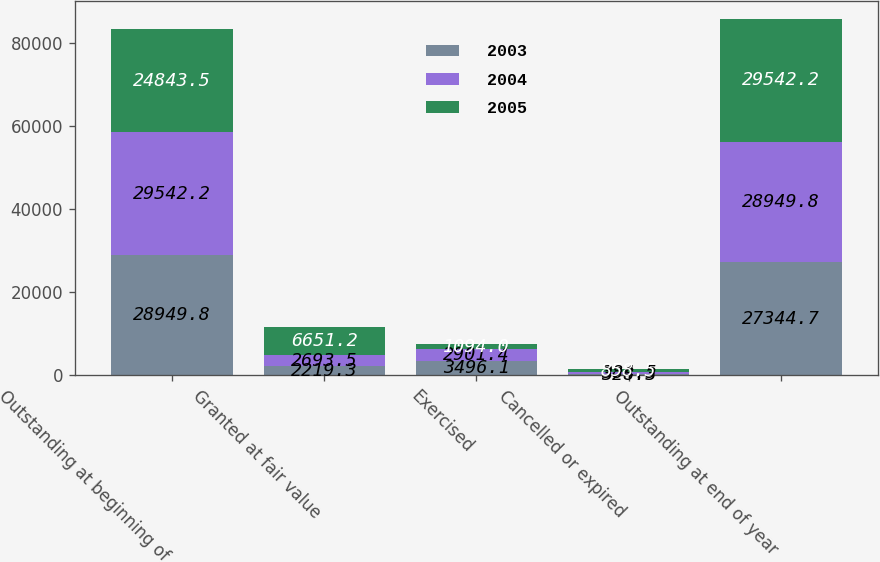Convert chart to OTSL. <chart><loc_0><loc_0><loc_500><loc_500><stacked_bar_chart><ecel><fcel>Outstanding at beginning of<fcel>Granted at fair value<fcel>Exercised<fcel>Cancelled or expired<fcel>Outstanding at end of year<nl><fcel>2003<fcel>28949.8<fcel>2219.3<fcel>3496.1<fcel>328.3<fcel>27344.7<nl><fcel>2004<fcel>29542.2<fcel>2693.5<fcel>2901.4<fcel>384.5<fcel>28949.8<nl><fcel>2005<fcel>24843.5<fcel>6651.2<fcel>1094<fcel>858.5<fcel>29542.2<nl></chart> 